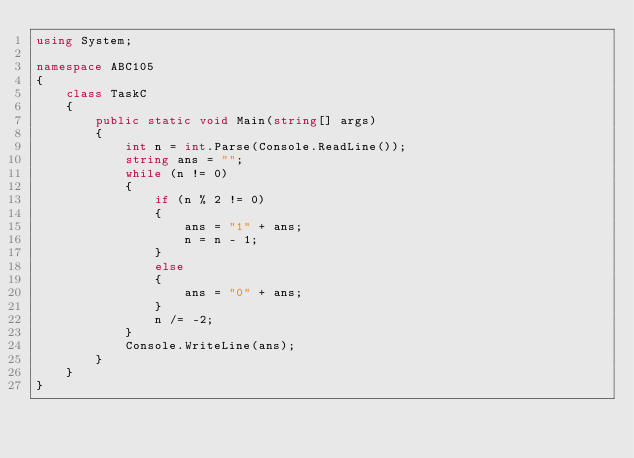Convert code to text. <code><loc_0><loc_0><loc_500><loc_500><_C#_>using System;

namespace ABC105
{
    class TaskC
    {
        public static void Main(string[] args)
        {
            int n = int.Parse(Console.ReadLine());
            string ans = "";
            while (n != 0)
            {
                if (n % 2 != 0)
                {
                    ans = "1" + ans;
                    n = n - 1;
                }
                else
                {
                    ans = "0" + ans;
                }
                n /= -2;
            }
            Console.WriteLine(ans);
        }
    }
}</code> 